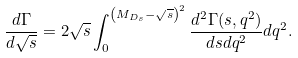Convert formula to latex. <formula><loc_0><loc_0><loc_500><loc_500>\frac { d \Gamma } { d \sqrt { s } } = 2 \sqrt { s } \int _ { 0 } ^ { \left ( M _ { D _ { s } } - \sqrt { s } \right ) ^ { 2 } } \frac { d ^ { 2 } \Gamma ( s , q ^ { 2 } ) } { d s d q ^ { 2 } } d q ^ { 2 } .</formula> 